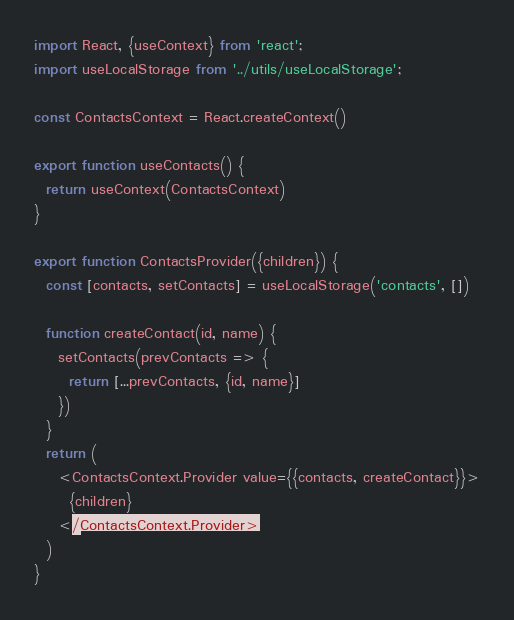Convert code to text. <code><loc_0><loc_0><loc_500><loc_500><_JavaScript_>import React, {useContext} from 'react';
import useLocalStorage from '../utils/useLocalStorage';

const ContactsContext = React.createContext()

export function useContacts() {
  return useContext(ContactsContext)
}

export function ContactsProvider({children}) {
  const [contacts, setContacts] = useLocalStorage('contacts', [])

  function createContact(id, name) {
    setContacts(prevContacts => {
      return [...prevContacts, {id, name}]
    })
  }
  return (
    <ContactsContext.Provider value={{contacts, createContact}}>
      {children}
    </ContactsContext.Provider>
  )
}
</code> 